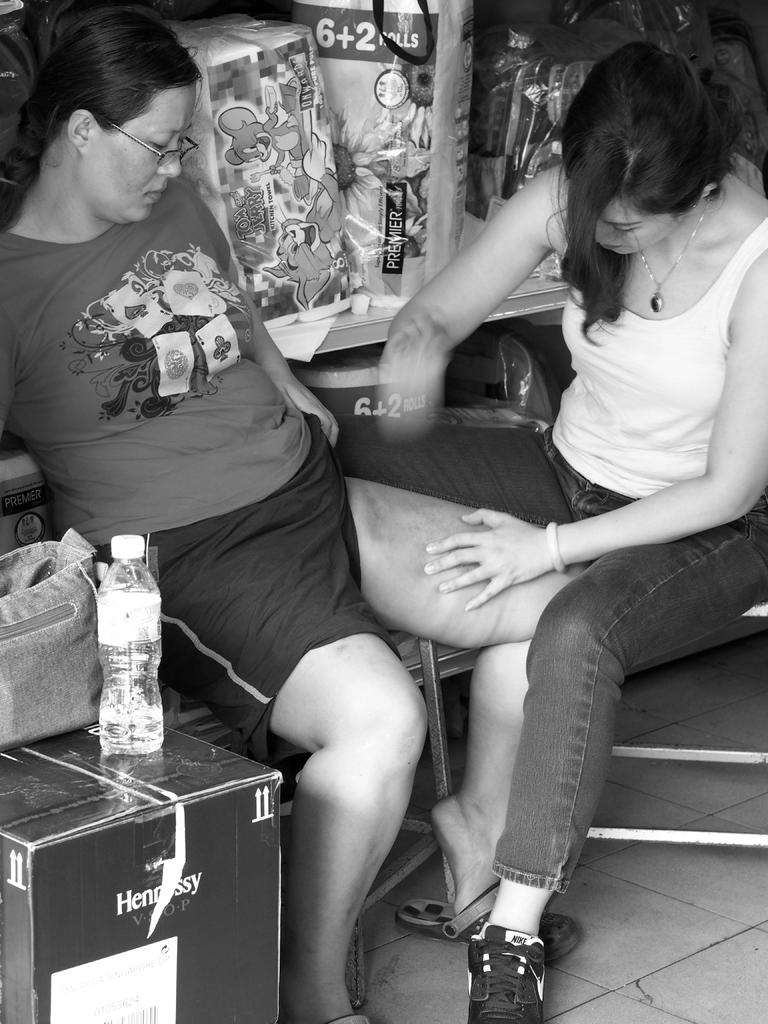How many women are in the image? There are two women in the image. What is the right side woman doing with the left side woman? The right side woman is holding the left side woman's leg. What object is in front of the women? There is a bottle in front of the women. Where is the bag located in the image? The bag is on a box in the image. What type of cloud can be seen in the image? There are no clouds present in the image. Is the sofa visible in the image? There is no sofa present in the image. 